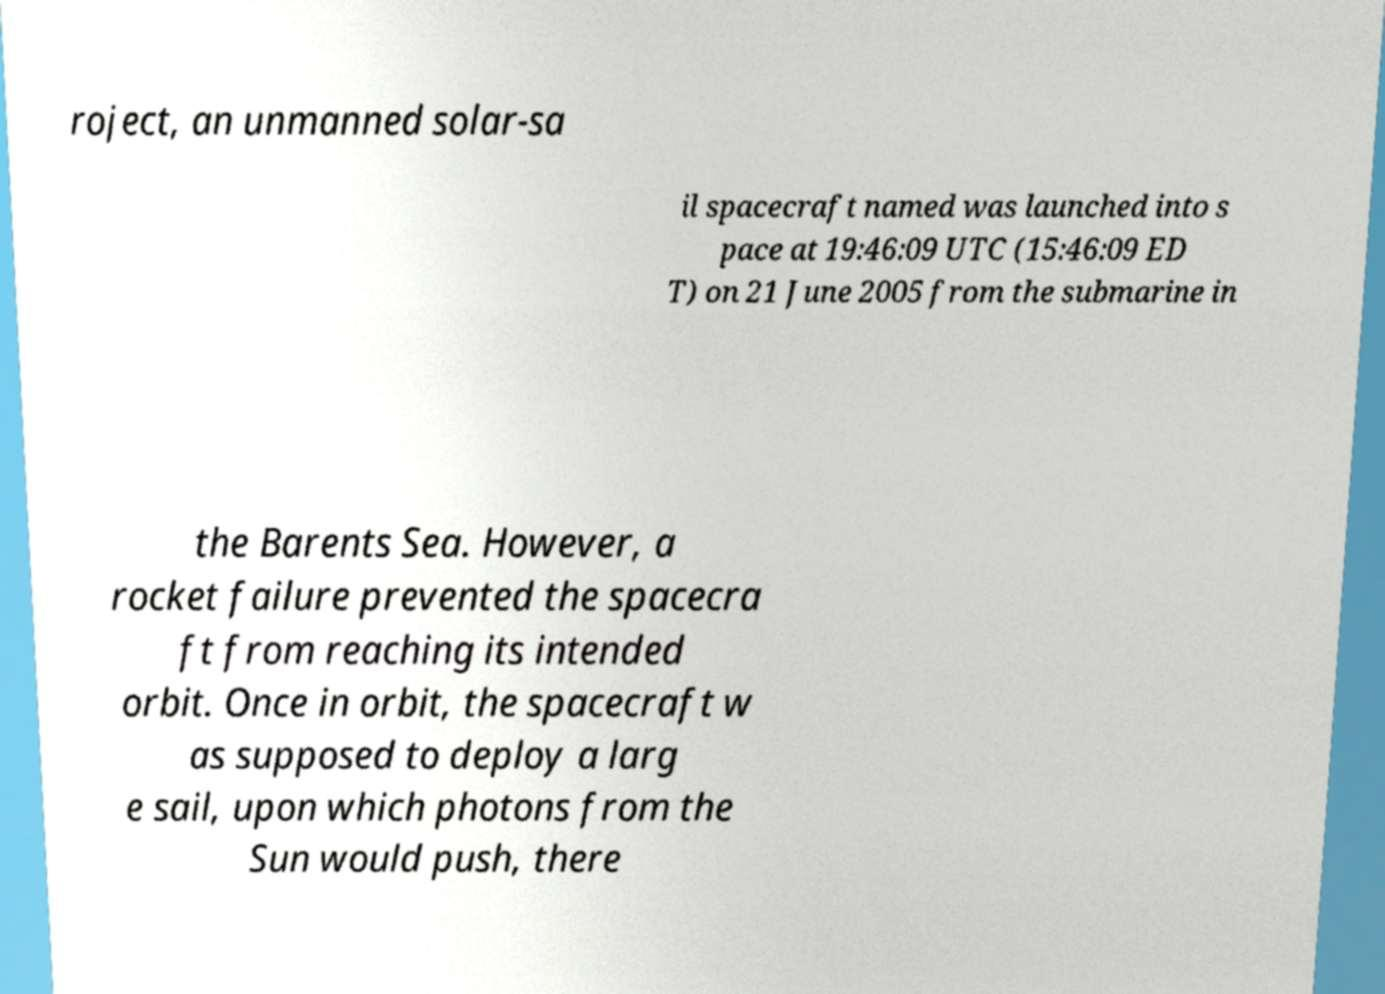Could you extract and type out the text from this image? roject, an unmanned solar-sa il spacecraft named was launched into s pace at 19:46:09 UTC (15:46:09 ED T) on 21 June 2005 from the submarine in the Barents Sea. However, a rocket failure prevented the spacecra ft from reaching its intended orbit. Once in orbit, the spacecraft w as supposed to deploy a larg e sail, upon which photons from the Sun would push, there 